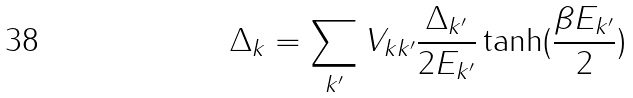Convert formula to latex. <formula><loc_0><loc_0><loc_500><loc_500>\Delta _ { k } = \sum _ { k ^ { \prime } } V _ { k k ^ { \prime } } \frac { \Delta _ { k ^ { \prime } } } { 2 E _ { k ^ { \prime } } } \tanh ( \frac { \beta E _ { k ^ { \prime } } } { 2 } )</formula> 